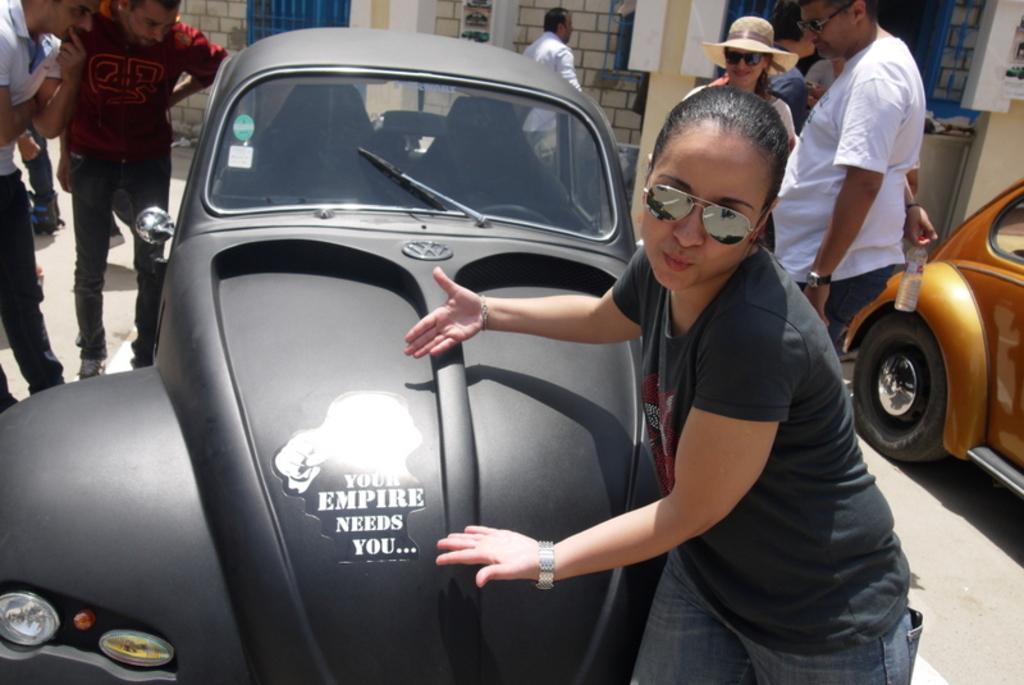In one or two sentences, can you explain what this image depicts? In this image we can see some persons standing near the black car which is of Volkswagen and a person wearing black color T-shirt, blue color jeans standing in front of car and posing for a photograph and in the background of the image there is wall, on right side of the image there is another car which is of different color. 